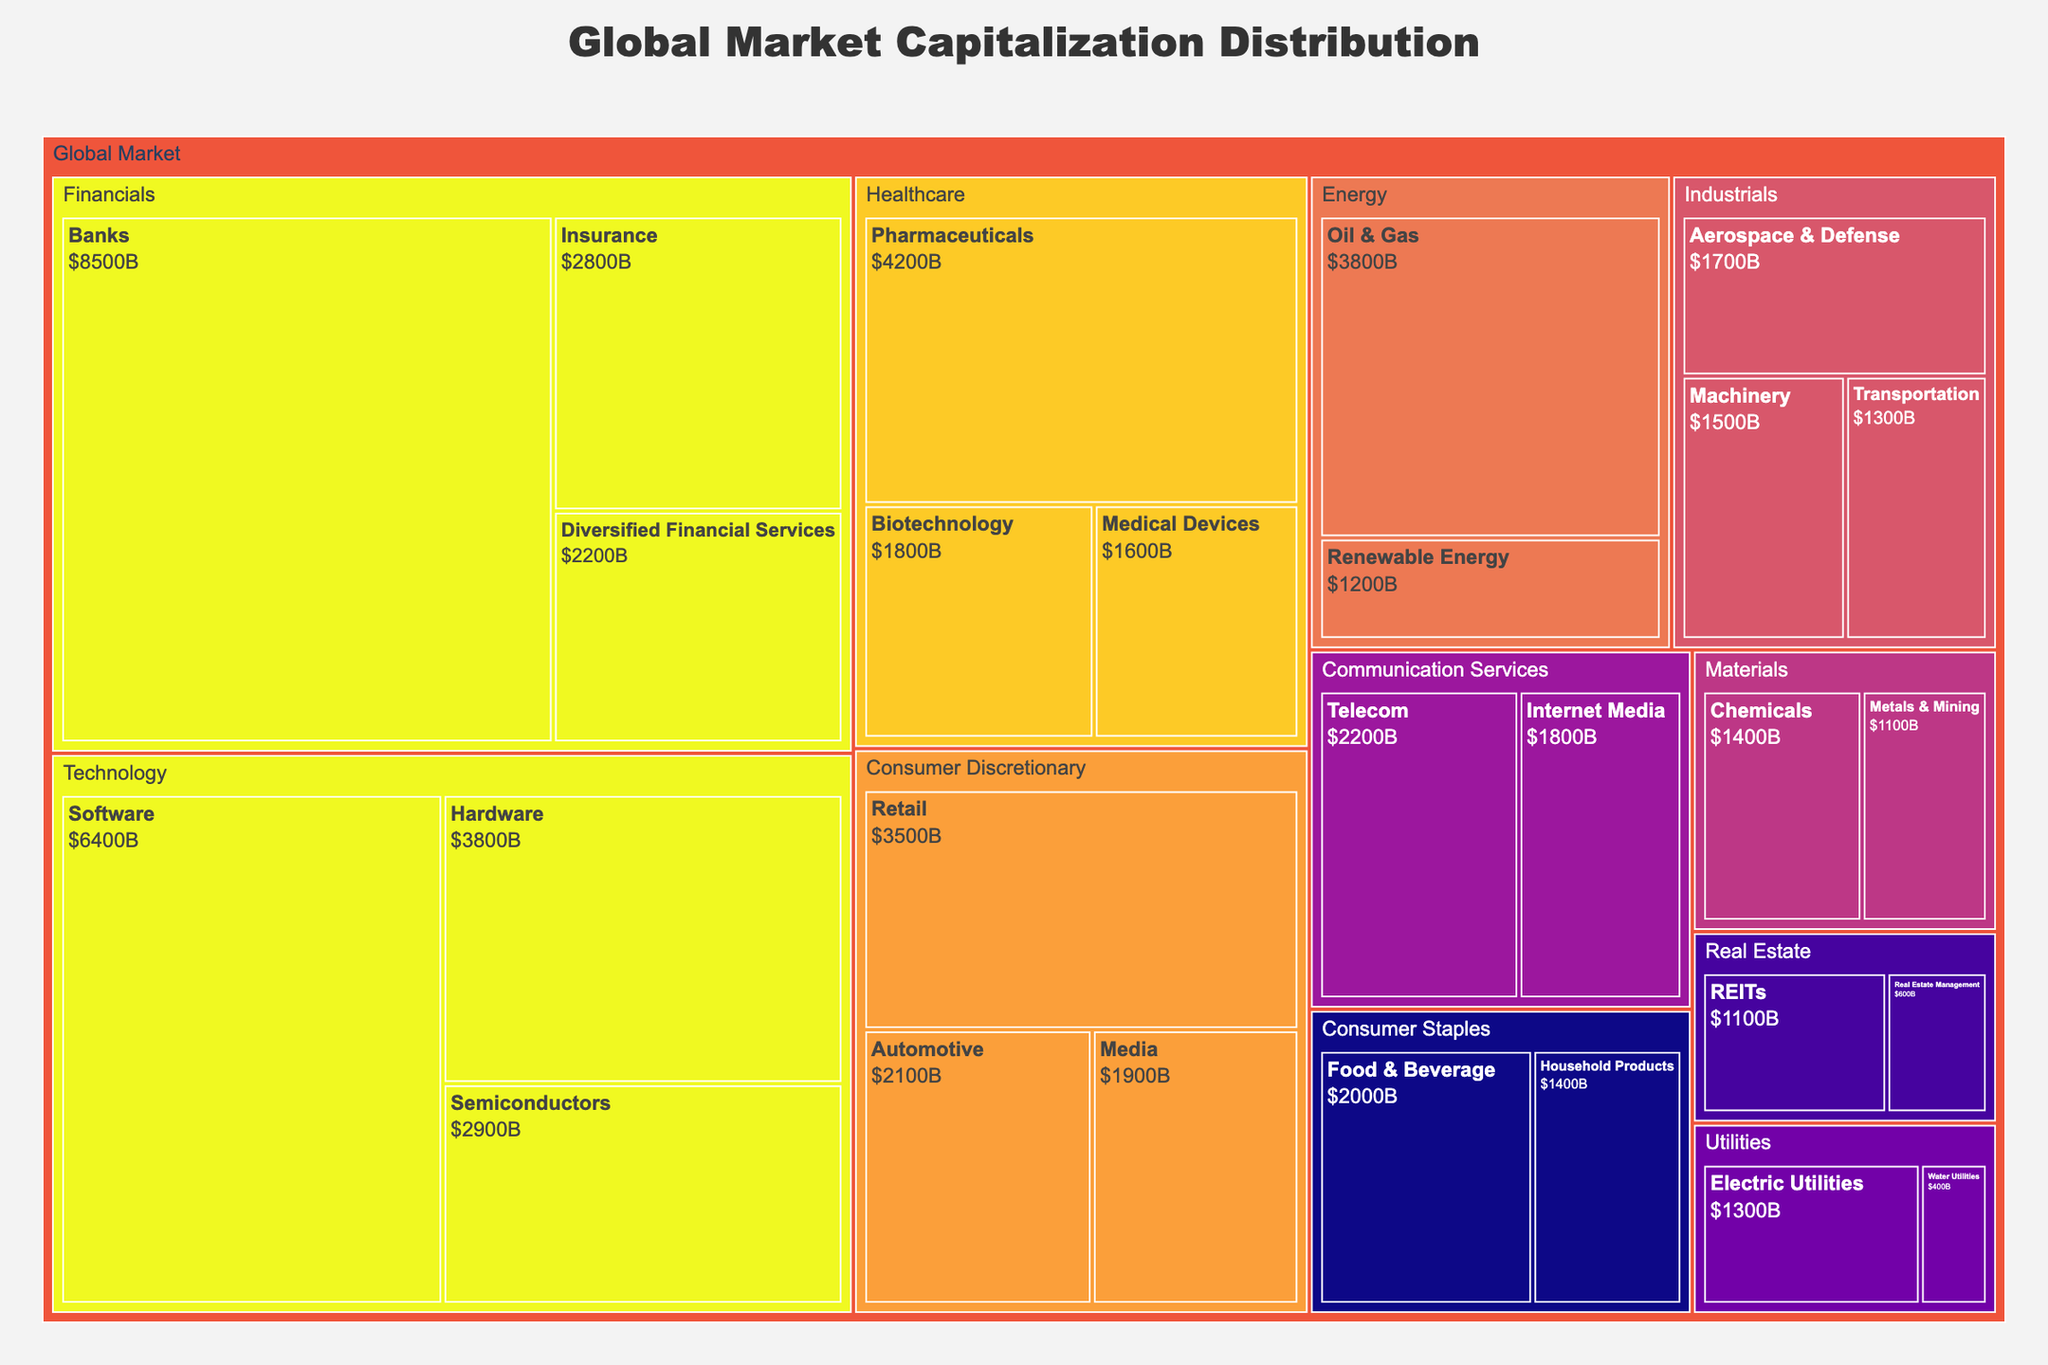What is the title of the treemap? The title is typically located at the top of the treemap. Here, it can be read as "Global Market Capitalization Distribution".
Answer: Global Market Capitalization Distribution Which sector has the highest market capitalization? To find the sector with the highest market capitalization, look for the largest rectangle within the "Global Market" section. The Financials sector is the largest.
Answer: Financials How much is the total market capitalization of the Healthcare sector? Locate the Healthcare sector on the treemap and refer to the hover information which gives the sector total. The total market capitalization for Healthcare is $7600B.
Answer: $7600B Which sector has the least market capitalization? Look for the smallest rectangle within the "Global Market" section. The smallest sector is Real Estate.
Answer: Real Estate What is the combined market capitalization of the Technology and Energy sectors? First, find the market capitalization for each sector individually: Technology ($13100B) and Energy ($5000B). Then, add them together: $13100B + $5000B = $18100B.
Answer: $18100B Compare the market capitalization of Software and Semiconductors industries within the Technology sector. Which is larger? Identify the two rectangles within the Technology sector and compare their sizes. The Software industry has a market cap of $6400B, which is larger than Semiconductors at $2900B.
Answer: Software What is the difference in market capitalization between the Healthcare and Consumer Discretionary sectors? Subtract the market capitalization of Consumer Discretionary ($7500B) from Healthcare ($7600B): $7600B - $7500B = $100B.
Answer: $100B How does the market capitalization of the Telecom industry compare to that of the Automotive industry? Find the respective industries and compare their values. The Telecom industry has a market cap of $2200B and Automotive industry has $2100B; Telecom is slightly larger.
Answer: Telecom What is the market capitalization of the largest industry in the Financials sector? Within the Financials sector, find the industry with the largest rectangle, which is Banks with $8500B.
Answer: $8500B Which sector contains the industry with the highest individual market cap? Look for the single largest rectangle across all sectors. The largest individual industry is Banks under the Financials sector.
Answer: Financials 